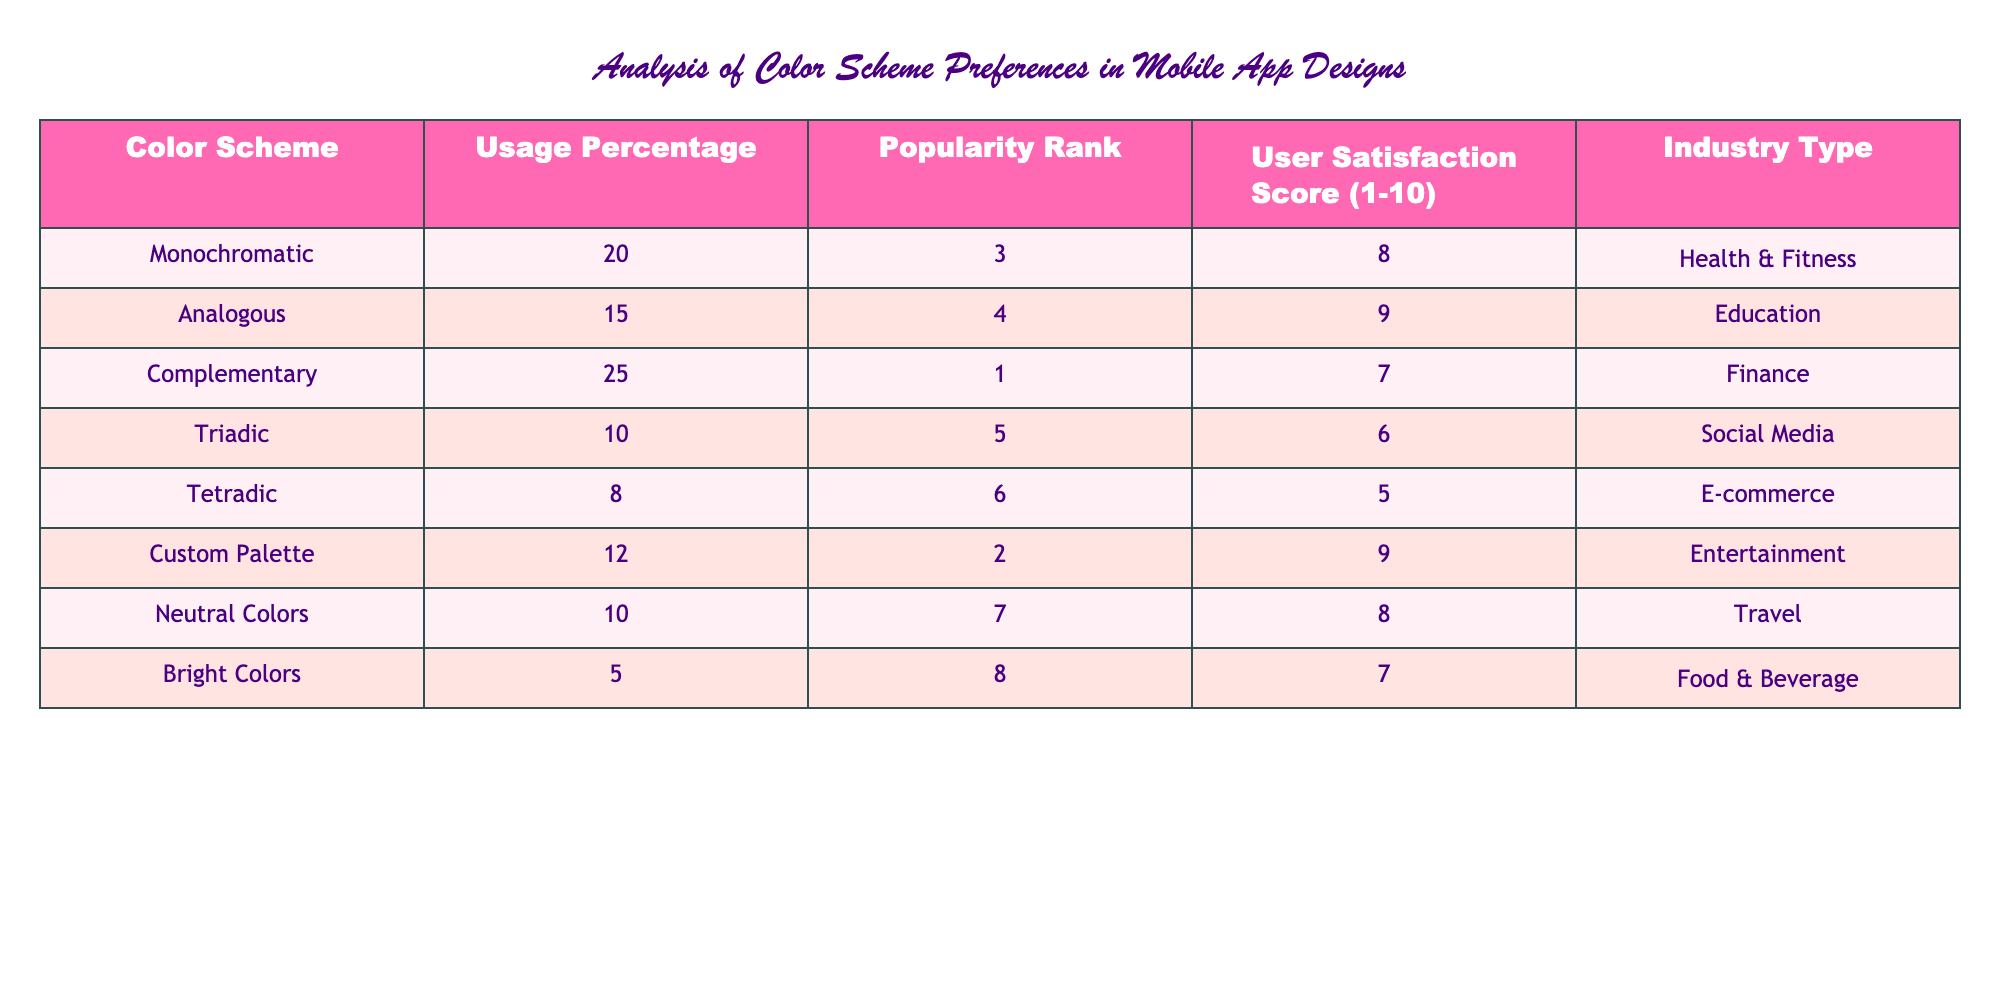What is the highest popularity rank in the table? The popularity rank values listed are 3, 4, 1, 5, 6, 2, 7, and 8. The highest value among these is 1.
Answer: 1 Which color scheme has the highest user satisfaction score? The user satisfaction scores are 8, 9, 7, 6, 5, 9, 8, and 7 for the respective color schemes. The highest score among these is 9, corresponding to the colors Analogous and Custom Palette.
Answer: 9 What is the average usage percentage of Triadic and Tetradic color schemes? The usage percentages for Triadic and Tetradic are 10% and 8%, respectively. To find the average, sum these values (10 + 8) = 18%, then divide by 2 to get 18/2 = 9%.
Answer: 9% Is there a color scheme with a usage percentage higher than 20%? The usage percentages listed are 20%, 15%, 25%, 10%, 8%, 12%, 10%, and 5%. The value that exceeds 20% is 25%.
Answer: Yes Which industry type has the least popular color scheme? Looking at the popularity ranks, Tetradic is ranked 6th, which is the lowest rank. The corresponding industry for this color scheme is E-commerce.
Answer: E-commerce What is the total user satisfaction score for the color schemes used in the Health & Fitness and Education industries? The user satisfaction scores for Health & Fitness (Monochromatic) and Education (Analogous) are 8 and 9, respectively. Adding these scores gives a total of (8 + 9) = 17.
Answer: 17 How many color schemes have a user satisfaction score of 8 or higher? The color schemes with scores of 8 or higher are Monochromatic (8), Analogous (9), Custom Palette (9), and Neutral Colors (8). This gives a total of 4 color schemes.
Answer: 4 What percentage of the color schemes in the table have a usage percentage less than 15%? The color schemes with usage percentages less than 15% are Tetradic (8%) and Bright Colors (5%). There are 2 such schemes out of a total of 8, giving a percentage of (2/8) * 100 = 25%.
Answer: 25% 